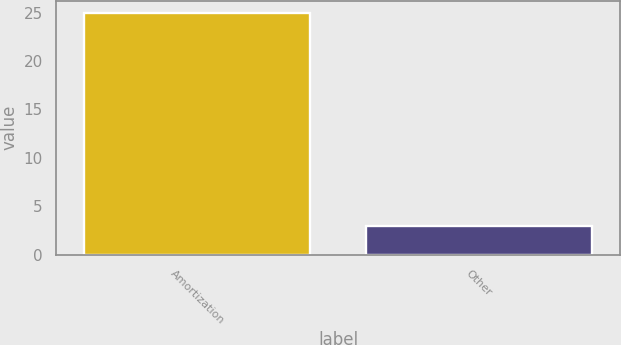<chart> <loc_0><loc_0><loc_500><loc_500><bar_chart><fcel>Amortization<fcel>Other<nl><fcel>25<fcel>3<nl></chart> 